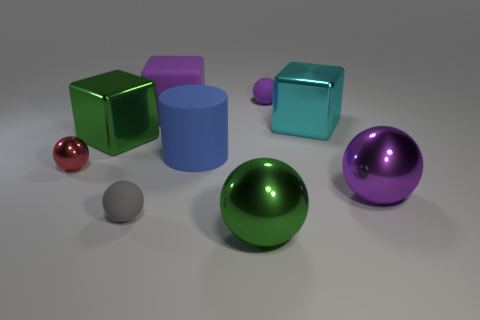Subtract all red spheres. How many spheres are left? 4 Subtract all green cubes. How many cubes are left? 2 Subtract all red blocks. How many purple spheres are left? 2 Add 1 gray objects. How many objects exist? 10 Subtract all cubes. How many objects are left? 6 Subtract 3 spheres. How many spheres are left? 2 Add 5 big purple metallic objects. How many big purple metallic objects exist? 6 Subtract 0 cyan cylinders. How many objects are left? 9 Subtract all purple cylinders. Subtract all gray spheres. How many cylinders are left? 1 Subtract all large blue objects. Subtract all large cyan metal objects. How many objects are left? 7 